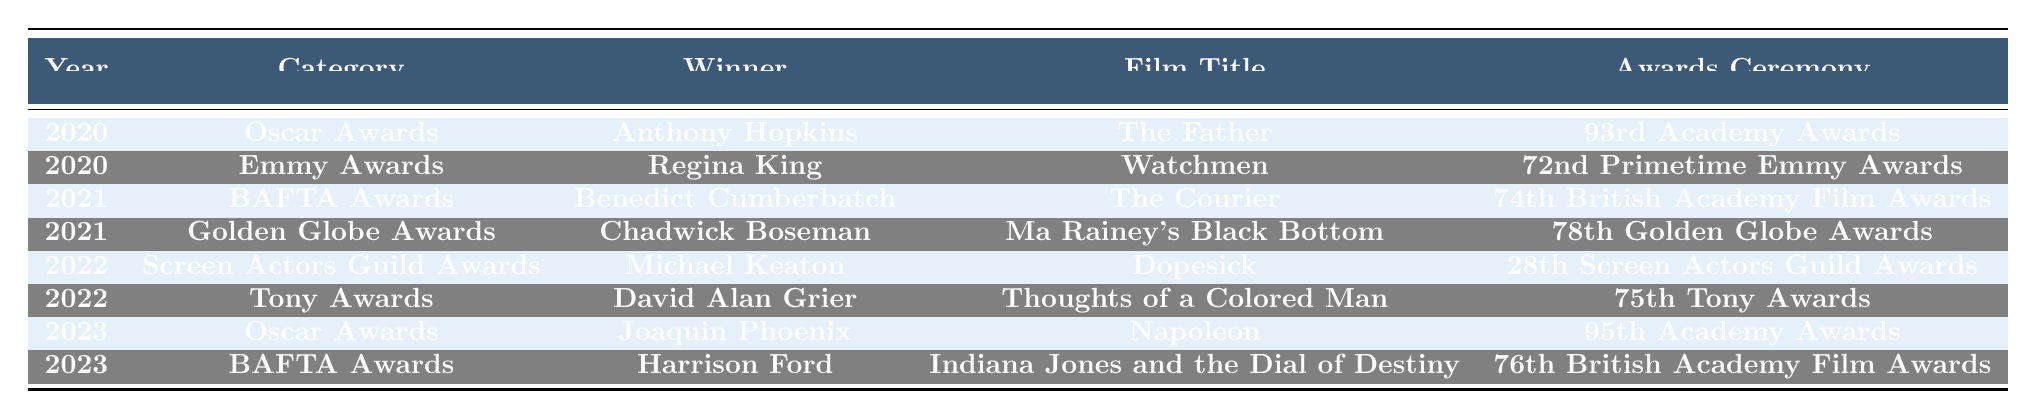What actor won the Oscar Award in 2020? The table indicates that Anthony Hopkins won the Oscar Award in 2020, specifically for the film "The Father".
Answer: Anthony Hopkins How many different awards did veteran actors win in 2022? In 2022, there are two awards listed: the Screen Actors Guild Award won by Michael Keaton and the Tony Award won by David Alan Grier. Therefore, there were 2 awards.
Answer: 2 Which actor won the BAFTA Award in 2023? The table shows that Harrison Ford won the BAFTA Award in 2023 for "Indiana Jones and the Dial of Destiny".
Answer: Harrison Ford Compare the Oscar winners of 2020 and 2023. Who were they? The Oscar winner in 2020 was Anthony Hopkins for "The Father" and in 2023 it was Joaquin Phoenix for "Napoleon".
Answer: Anthony Hopkins and Joaquin Phoenix Was Chadwick Boseman a winner in the Emmy Awards according to the table? The table does not list Chadwick Boseman as a winner in the Emmy Awards; instead, it lists him as a winner in the Golden Globe Awards in 2021.
Answer: No What is the total number of awards won in the years 2020 and 2021? In 2020, there were 2 awards (Oscar and Emmy) and in 2021, there were also 2 awards (BAFTA and Golden Globe), so the total is 2 + 2 = 4 awards.
Answer: 4 List the years in which award winners appeared for the film "Watchmen." "Watchmen" appears in the table under the Emmy Awards won by Regina King in 2020. No other years feature this film. Thus, the year is 2020.
Answer: 2020 Who won more than one award across the years listed? The table does not show any actor who won multiple awards across the years listed; each entry corresponds to a single award for that specific year.
Answer: None What was the film title associated with the Tony Award winner in 2022? The table indicates that the Tony Award winner in 2022 was David Alan Grier for the film "Thoughts of a Colored Man."
Answer: Thoughts of a Colored Man How many total awards were handed out from 2020 to 2023? The table presents a total of 8 awards given from 2020 to 2023 (2 in 2020, 2 in 2021, 2 in 2022, and 2 in 2023), showing a consistent number of awards each year.
Answer: 8 